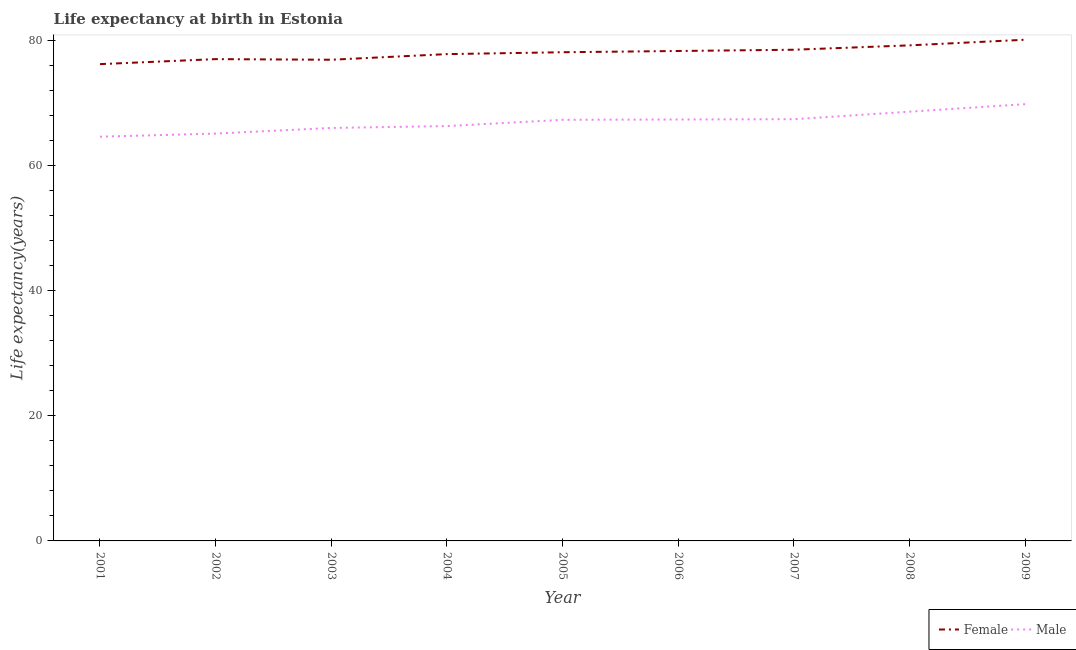How many different coloured lines are there?
Ensure brevity in your answer.  2. Is the number of lines equal to the number of legend labels?
Ensure brevity in your answer.  Yes. What is the life expectancy(female) in 2001?
Give a very brief answer. 76.2. Across all years, what is the maximum life expectancy(male)?
Give a very brief answer. 69.8. Across all years, what is the minimum life expectancy(female)?
Ensure brevity in your answer.  76.2. In which year was the life expectancy(male) maximum?
Offer a very short reply. 2009. What is the total life expectancy(female) in the graph?
Offer a terse response. 702.1. What is the difference between the life expectancy(female) in 2004 and that in 2009?
Provide a short and direct response. -2.3. What is the difference between the life expectancy(male) in 2003 and the life expectancy(female) in 2005?
Offer a very short reply. -12.1. What is the average life expectancy(female) per year?
Your answer should be very brief. 78.01. In the year 2003, what is the difference between the life expectancy(male) and life expectancy(female)?
Your answer should be very brief. -10.9. What is the ratio of the life expectancy(male) in 2004 to that in 2009?
Your answer should be compact. 0.95. Is the difference between the life expectancy(male) in 2007 and 2009 greater than the difference between the life expectancy(female) in 2007 and 2009?
Provide a succinct answer. No. What is the difference between the highest and the second highest life expectancy(female)?
Give a very brief answer. 0.9. What is the difference between the highest and the lowest life expectancy(male)?
Keep it short and to the point. 5.2. In how many years, is the life expectancy(male) greater than the average life expectancy(male) taken over all years?
Provide a succinct answer. 5. Is the life expectancy(male) strictly greater than the life expectancy(female) over the years?
Your answer should be compact. No. Is the life expectancy(female) strictly less than the life expectancy(male) over the years?
Offer a very short reply. No. How many lines are there?
Offer a terse response. 2. What is the difference between two consecutive major ticks on the Y-axis?
Your response must be concise. 20. Does the graph contain any zero values?
Keep it short and to the point. No. Where does the legend appear in the graph?
Offer a very short reply. Bottom right. How many legend labels are there?
Ensure brevity in your answer.  2. What is the title of the graph?
Give a very brief answer. Life expectancy at birth in Estonia. Does "Passenger Transport Items" appear as one of the legend labels in the graph?
Your answer should be compact. No. What is the label or title of the X-axis?
Your answer should be compact. Year. What is the label or title of the Y-axis?
Your answer should be very brief. Life expectancy(years). What is the Life expectancy(years) in Female in 2001?
Give a very brief answer. 76.2. What is the Life expectancy(years) of Male in 2001?
Your response must be concise. 64.6. What is the Life expectancy(years) of Female in 2002?
Offer a very short reply. 77. What is the Life expectancy(years) in Male in 2002?
Ensure brevity in your answer.  65.1. What is the Life expectancy(years) in Female in 2003?
Provide a short and direct response. 76.9. What is the Life expectancy(years) in Female in 2004?
Your answer should be very brief. 77.8. What is the Life expectancy(years) of Male in 2004?
Your answer should be compact. 66.3. What is the Life expectancy(years) in Female in 2005?
Give a very brief answer. 78.1. What is the Life expectancy(years) of Male in 2005?
Make the answer very short. 67.3. What is the Life expectancy(years) in Female in 2006?
Make the answer very short. 78.3. What is the Life expectancy(years) in Male in 2006?
Your answer should be very brief. 67.35. What is the Life expectancy(years) of Female in 2007?
Offer a very short reply. 78.5. What is the Life expectancy(years) of Male in 2007?
Provide a short and direct response. 67.4. What is the Life expectancy(years) in Female in 2008?
Make the answer very short. 79.2. What is the Life expectancy(years) of Male in 2008?
Make the answer very short. 68.6. What is the Life expectancy(years) in Female in 2009?
Your answer should be very brief. 80.1. What is the Life expectancy(years) of Male in 2009?
Provide a succinct answer. 69.8. Across all years, what is the maximum Life expectancy(years) of Female?
Offer a very short reply. 80.1. Across all years, what is the maximum Life expectancy(years) in Male?
Keep it short and to the point. 69.8. Across all years, what is the minimum Life expectancy(years) of Female?
Ensure brevity in your answer.  76.2. Across all years, what is the minimum Life expectancy(years) in Male?
Provide a succinct answer. 64.6. What is the total Life expectancy(years) of Female in the graph?
Offer a terse response. 702.1. What is the total Life expectancy(years) in Male in the graph?
Provide a short and direct response. 602.45. What is the difference between the Life expectancy(years) of Male in 2001 and that in 2003?
Keep it short and to the point. -1.4. What is the difference between the Life expectancy(years) of Female in 2001 and that in 2005?
Provide a succinct answer. -1.9. What is the difference between the Life expectancy(years) of Female in 2001 and that in 2006?
Provide a short and direct response. -2.1. What is the difference between the Life expectancy(years) of Male in 2001 and that in 2006?
Your response must be concise. -2.75. What is the difference between the Life expectancy(years) in Female in 2001 and that in 2007?
Provide a succinct answer. -2.3. What is the difference between the Life expectancy(years) in Male in 2001 and that in 2007?
Your answer should be very brief. -2.8. What is the difference between the Life expectancy(years) of Female in 2001 and that in 2008?
Offer a terse response. -3. What is the difference between the Life expectancy(years) in Male in 2001 and that in 2008?
Your answer should be very brief. -4. What is the difference between the Life expectancy(years) in Female in 2001 and that in 2009?
Make the answer very short. -3.9. What is the difference between the Life expectancy(years) in Male in 2002 and that in 2003?
Give a very brief answer. -0.9. What is the difference between the Life expectancy(years) of Female in 2002 and that in 2004?
Ensure brevity in your answer.  -0.8. What is the difference between the Life expectancy(years) of Female in 2002 and that in 2005?
Offer a very short reply. -1.1. What is the difference between the Life expectancy(years) in Male in 2002 and that in 2005?
Your response must be concise. -2.2. What is the difference between the Life expectancy(years) in Male in 2002 and that in 2006?
Your response must be concise. -2.25. What is the difference between the Life expectancy(years) in Male in 2002 and that in 2007?
Make the answer very short. -2.3. What is the difference between the Life expectancy(years) in Female in 2002 and that in 2009?
Provide a succinct answer. -3.1. What is the difference between the Life expectancy(years) in Male in 2002 and that in 2009?
Your answer should be compact. -4.7. What is the difference between the Life expectancy(years) in Male in 2003 and that in 2005?
Keep it short and to the point. -1.3. What is the difference between the Life expectancy(years) of Female in 2003 and that in 2006?
Provide a short and direct response. -1.4. What is the difference between the Life expectancy(years) of Male in 2003 and that in 2006?
Provide a succinct answer. -1.35. What is the difference between the Life expectancy(years) of Female in 2003 and that in 2009?
Your answer should be compact. -3.2. What is the difference between the Life expectancy(years) in Male in 2004 and that in 2006?
Your response must be concise. -1.05. What is the difference between the Life expectancy(years) of Male in 2004 and that in 2008?
Ensure brevity in your answer.  -2.3. What is the difference between the Life expectancy(years) of Female in 2004 and that in 2009?
Keep it short and to the point. -2.3. What is the difference between the Life expectancy(years) in Female in 2005 and that in 2008?
Provide a succinct answer. -1.1. What is the difference between the Life expectancy(years) in Female in 2005 and that in 2009?
Your answer should be very brief. -2. What is the difference between the Life expectancy(years) in Male in 2006 and that in 2007?
Your answer should be compact. -0.05. What is the difference between the Life expectancy(years) in Female in 2006 and that in 2008?
Make the answer very short. -0.9. What is the difference between the Life expectancy(years) of Male in 2006 and that in 2008?
Make the answer very short. -1.25. What is the difference between the Life expectancy(years) in Female in 2006 and that in 2009?
Your answer should be very brief. -1.8. What is the difference between the Life expectancy(years) in Male in 2006 and that in 2009?
Give a very brief answer. -2.45. What is the difference between the Life expectancy(years) of Female in 2007 and that in 2008?
Give a very brief answer. -0.7. What is the difference between the Life expectancy(years) of Male in 2007 and that in 2008?
Your answer should be compact. -1.2. What is the difference between the Life expectancy(years) of Male in 2007 and that in 2009?
Offer a terse response. -2.4. What is the difference between the Life expectancy(years) in Female in 2008 and that in 2009?
Your answer should be very brief. -0.9. What is the difference between the Life expectancy(years) in Male in 2008 and that in 2009?
Your answer should be very brief. -1.2. What is the difference between the Life expectancy(years) of Female in 2001 and the Life expectancy(years) of Male in 2005?
Give a very brief answer. 8.9. What is the difference between the Life expectancy(years) in Female in 2001 and the Life expectancy(years) in Male in 2006?
Offer a very short reply. 8.85. What is the difference between the Life expectancy(years) in Female in 2001 and the Life expectancy(years) in Male in 2007?
Provide a short and direct response. 8.8. What is the difference between the Life expectancy(years) in Female in 2002 and the Life expectancy(years) in Male in 2004?
Your response must be concise. 10.7. What is the difference between the Life expectancy(years) in Female in 2002 and the Life expectancy(years) in Male in 2006?
Offer a very short reply. 9.65. What is the difference between the Life expectancy(years) of Female in 2002 and the Life expectancy(years) of Male in 2007?
Provide a succinct answer. 9.6. What is the difference between the Life expectancy(years) in Female in 2003 and the Life expectancy(years) in Male in 2005?
Provide a short and direct response. 9.6. What is the difference between the Life expectancy(years) of Female in 2003 and the Life expectancy(years) of Male in 2006?
Offer a terse response. 9.55. What is the difference between the Life expectancy(years) in Female in 2003 and the Life expectancy(years) in Male in 2008?
Your answer should be very brief. 8.3. What is the difference between the Life expectancy(years) in Female in 2004 and the Life expectancy(years) in Male in 2005?
Offer a terse response. 10.5. What is the difference between the Life expectancy(years) in Female in 2004 and the Life expectancy(years) in Male in 2006?
Make the answer very short. 10.45. What is the difference between the Life expectancy(years) of Female in 2004 and the Life expectancy(years) of Male in 2008?
Ensure brevity in your answer.  9.2. What is the difference between the Life expectancy(years) of Female in 2004 and the Life expectancy(years) of Male in 2009?
Give a very brief answer. 8. What is the difference between the Life expectancy(years) of Female in 2005 and the Life expectancy(years) of Male in 2006?
Make the answer very short. 10.75. What is the difference between the Life expectancy(years) in Female in 2005 and the Life expectancy(years) in Male in 2008?
Provide a succinct answer. 9.5. What is the difference between the Life expectancy(years) in Female in 2005 and the Life expectancy(years) in Male in 2009?
Give a very brief answer. 8.3. What is the difference between the Life expectancy(years) of Female in 2006 and the Life expectancy(years) of Male in 2007?
Your response must be concise. 10.9. What is the difference between the Life expectancy(years) in Female in 2007 and the Life expectancy(years) in Male in 2008?
Offer a terse response. 9.9. What is the difference between the Life expectancy(years) of Female in 2008 and the Life expectancy(years) of Male in 2009?
Offer a terse response. 9.4. What is the average Life expectancy(years) of Female per year?
Your answer should be compact. 78.01. What is the average Life expectancy(years) in Male per year?
Provide a succinct answer. 66.94. In the year 2001, what is the difference between the Life expectancy(years) in Female and Life expectancy(years) in Male?
Ensure brevity in your answer.  11.6. In the year 2003, what is the difference between the Life expectancy(years) in Female and Life expectancy(years) in Male?
Offer a terse response. 10.9. In the year 2004, what is the difference between the Life expectancy(years) in Female and Life expectancy(years) in Male?
Provide a succinct answer. 11.5. In the year 2006, what is the difference between the Life expectancy(years) of Female and Life expectancy(years) of Male?
Your response must be concise. 10.95. In the year 2008, what is the difference between the Life expectancy(years) in Female and Life expectancy(years) in Male?
Your answer should be very brief. 10.6. In the year 2009, what is the difference between the Life expectancy(years) of Female and Life expectancy(years) of Male?
Your response must be concise. 10.3. What is the ratio of the Life expectancy(years) of Female in 2001 to that in 2002?
Your answer should be very brief. 0.99. What is the ratio of the Life expectancy(years) of Male in 2001 to that in 2002?
Ensure brevity in your answer.  0.99. What is the ratio of the Life expectancy(years) in Female in 2001 to that in 2003?
Your response must be concise. 0.99. What is the ratio of the Life expectancy(years) of Male in 2001 to that in 2003?
Your answer should be very brief. 0.98. What is the ratio of the Life expectancy(years) in Female in 2001 to that in 2004?
Ensure brevity in your answer.  0.98. What is the ratio of the Life expectancy(years) in Male in 2001 to that in 2004?
Provide a short and direct response. 0.97. What is the ratio of the Life expectancy(years) of Female in 2001 to that in 2005?
Keep it short and to the point. 0.98. What is the ratio of the Life expectancy(years) in Male in 2001 to that in 2005?
Offer a very short reply. 0.96. What is the ratio of the Life expectancy(years) in Female in 2001 to that in 2006?
Provide a succinct answer. 0.97. What is the ratio of the Life expectancy(years) in Male in 2001 to that in 2006?
Your response must be concise. 0.96. What is the ratio of the Life expectancy(years) of Female in 2001 to that in 2007?
Make the answer very short. 0.97. What is the ratio of the Life expectancy(years) in Male in 2001 to that in 2007?
Your answer should be compact. 0.96. What is the ratio of the Life expectancy(years) in Female in 2001 to that in 2008?
Ensure brevity in your answer.  0.96. What is the ratio of the Life expectancy(years) of Male in 2001 to that in 2008?
Give a very brief answer. 0.94. What is the ratio of the Life expectancy(years) of Female in 2001 to that in 2009?
Ensure brevity in your answer.  0.95. What is the ratio of the Life expectancy(years) of Male in 2001 to that in 2009?
Offer a terse response. 0.93. What is the ratio of the Life expectancy(years) in Female in 2002 to that in 2003?
Give a very brief answer. 1. What is the ratio of the Life expectancy(years) in Male in 2002 to that in 2003?
Offer a terse response. 0.99. What is the ratio of the Life expectancy(years) in Male in 2002 to that in 2004?
Make the answer very short. 0.98. What is the ratio of the Life expectancy(years) of Female in 2002 to that in 2005?
Your answer should be very brief. 0.99. What is the ratio of the Life expectancy(years) in Male in 2002 to that in 2005?
Your answer should be very brief. 0.97. What is the ratio of the Life expectancy(years) in Female in 2002 to that in 2006?
Your response must be concise. 0.98. What is the ratio of the Life expectancy(years) in Male in 2002 to that in 2006?
Offer a very short reply. 0.97. What is the ratio of the Life expectancy(years) of Female in 2002 to that in 2007?
Your answer should be compact. 0.98. What is the ratio of the Life expectancy(years) of Male in 2002 to that in 2007?
Your answer should be compact. 0.97. What is the ratio of the Life expectancy(years) in Female in 2002 to that in 2008?
Your response must be concise. 0.97. What is the ratio of the Life expectancy(years) in Male in 2002 to that in 2008?
Make the answer very short. 0.95. What is the ratio of the Life expectancy(years) in Female in 2002 to that in 2009?
Provide a short and direct response. 0.96. What is the ratio of the Life expectancy(years) in Male in 2002 to that in 2009?
Keep it short and to the point. 0.93. What is the ratio of the Life expectancy(years) of Female in 2003 to that in 2004?
Give a very brief answer. 0.99. What is the ratio of the Life expectancy(years) in Female in 2003 to that in 2005?
Keep it short and to the point. 0.98. What is the ratio of the Life expectancy(years) in Male in 2003 to that in 2005?
Offer a terse response. 0.98. What is the ratio of the Life expectancy(years) of Female in 2003 to that in 2006?
Your answer should be very brief. 0.98. What is the ratio of the Life expectancy(years) in Female in 2003 to that in 2007?
Provide a short and direct response. 0.98. What is the ratio of the Life expectancy(years) of Male in 2003 to that in 2007?
Provide a short and direct response. 0.98. What is the ratio of the Life expectancy(years) in Female in 2003 to that in 2008?
Your answer should be very brief. 0.97. What is the ratio of the Life expectancy(years) in Male in 2003 to that in 2008?
Provide a short and direct response. 0.96. What is the ratio of the Life expectancy(years) in Female in 2003 to that in 2009?
Give a very brief answer. 0.96. What is the ratio of the Life expectancy(years) of Male in 2003 to that in 2009?
Your response must be concise. 0.95. What is the ratio of the Life expectancy(years) in Male in 2004 to that in 2005?
Provide a succinct answer. 0.99. What is the ratio of the Life expectancy(years) in Female in 2004 to that in 2006?
Offer a very short reply. 0.99. What is the ratio of the Life expectancy(years) of Male in 2004 to that in 2006?
Keep it short and to the point. 0.98. What is the ratio of the Life expectancy(years) in Female in 2004 to that in 2007?
Offer a very short reply. 0.99. What is the ratio of the Life expectancy(years) of Male in 2004 to that in 2007?
Offer a terse response. 0.98. What is the ratio of the Life expectancy(years) in Female in 2004 to that in 2008?
Ensure brevity in your answer.  0.98. What is the ratio of the Life expectancy(years) of Male in 2004 to that in 2008?
Provide a succinct answer. 0.97. What is the ratio of the Life expectancy(years) of Female in 2004 to that in 2009?
Ensure brevity in your answer.  0.97. What is the ratio of the Life expectancy(years) in Male in 2004 to that in 2009?
Ensure brevity in your answer.  0.95. What is the ratio of the Life expectancy(years) of Female in 2005 to that in 2006?
Provide a succinct answer. 1. What is the ratio of the Life expectancy(years) of Female in 2005 to that in 2007?
Provide a short and direct response. 0.99. What is the ratio of the Life expectancy(years) in Male in 2005 to that in 2007?
Offer a very short reply. 1. What is the ratio of the Life expectancy(years) in Female in 2005 to that in 2008?
Provide a short and direct response. 0.99. What is the ratio of the Life expectancy(years) of Female in 2005 to that in 2009?
Provide a short and direct response. 0.97. What is the ratio of the Life expectancy(years) in Male in 2005 to that in 2009?
Provide a succinct answer. 0.96. What is the ratio of the Life expectancy(years) in Female in 2006 to that in 2007?
Your response must be concise. 1. What is the ratio of the Life expectancy(years) of Male in 2006 to that in 2007?
Offer a terse response. 1. What is the ratio of the Life expectancy(years) of Male in 2006 to that in 2008?
Your answer should be compact. 0.98. What is the ratio of the Life expectancy(years) of Female in 2006 to that in 2009?
Your answer should be compact. 0.98. What is the ratio of the Life expectancy(years) in Male in 2006 to that in 2009?
Provide a short and direct response. 0.96. What is the ratio of the Life expectancy(years) in Female in 2007 to that in 2008?
Give a very brief answer. 0.99. What is the ratio of the Life expectancy(years) in Male in 2007 to that in 2008?
Give a very brief answer. 0.98. What is the ratio of the Life expectancy(years) of Female in 2007 to that in 2009?
Ensure brevity in your answer.  0.98. What is the ratio of the Life expectancy(years) in Male in 2007 to that in 2009?
Your answer should be very brief. 0.97. What is the ratio of the Life expectancy(years) in Male in 2008 to that in 2009?
Keep it short and to the point. 0.98. What is the difference between the highest and the second highest Life expectancy(years) in Male?
Provide a short and direct response. 1.2. 